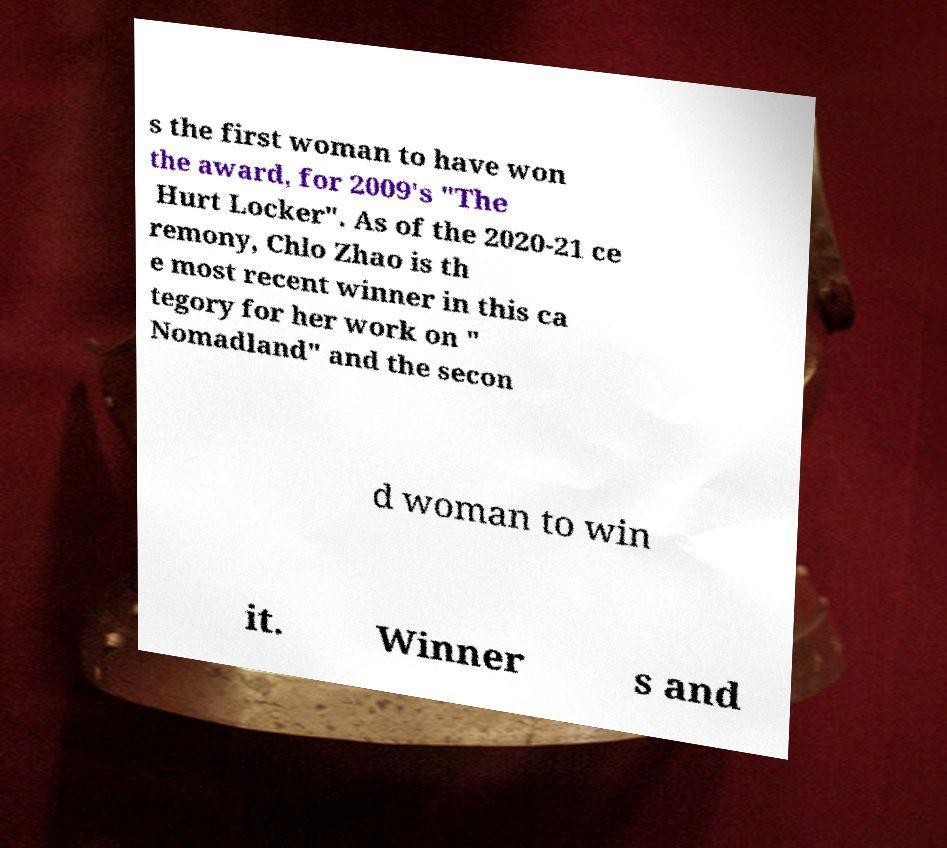Can you accurately transcribe the text from the provided image for me? s the first woman to have won the award, for 2009's "The Hurt Locker". As of the 2020-21 ce remony, Chlo Zhao is th e most recent winner in this ca tegory for her work on " Nomadland" and the secon d woman to win it. Winner s and 